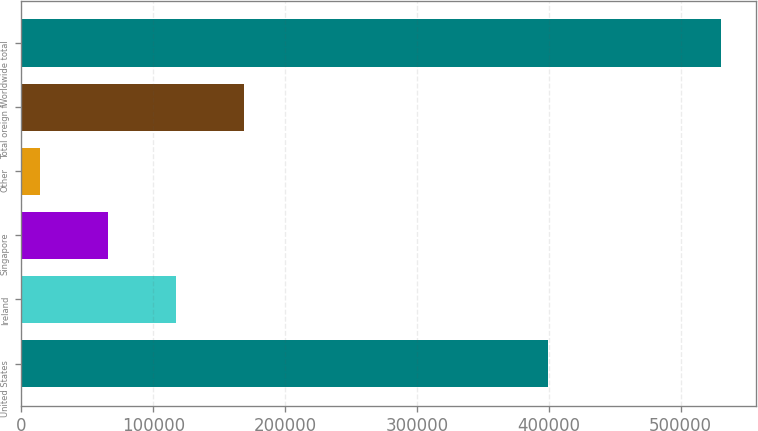Convert chart to OTSL. <chart><loc_0><loc_0><loc_500><loc_500><bar_chart><fcel>United States<fcel>Ireland<fcel>Singapore<fcel>Other<fcel>Total oreign f<fcel>Worldwide total<nl><fcel>399472<fcel>117370<fcel>65667.6<fcel>13965<fcel>169073<fcel>530991<nl></chart> 